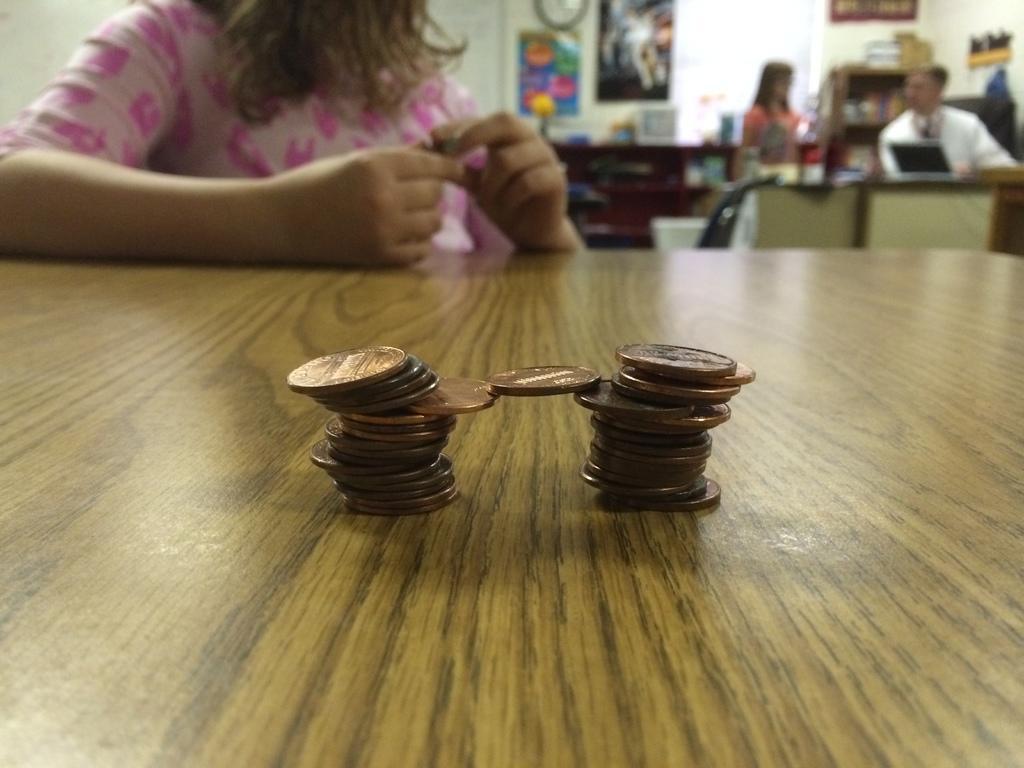Could you give a brief overview of what you see in this image? This coins are highlighted in this picture. This coins are kept on a table. This woman is sitting on a chair. For this 2 persons are there. In-front of this 2 persons there is a table, on table there is a laptop and things. On wall there are different type of posters and clock. This is a rack with things. 